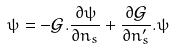Convert formula to latex. <formula><loc_0><loc_0><loc_500><loc_500>\psi = - { \mathcal { G } } . \frac { \partial \psi } { \partial n _ { s } } + \frac { \partial { \mathcal { G } } } { \partial n ^ { \prime } _ { s } } . \psi</formula> 